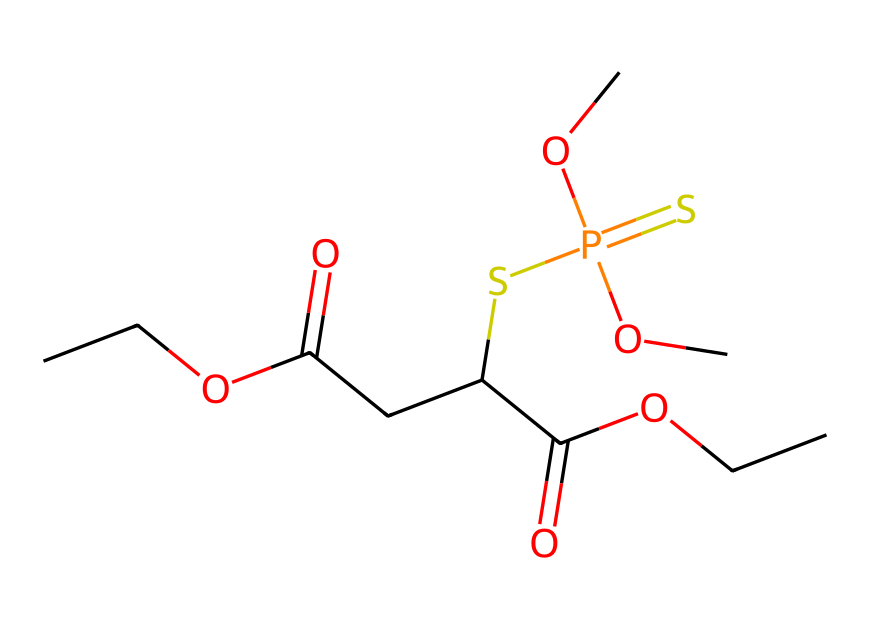How many carbon atoms are in malathion? By analyzing the SMILES representation, you can identify the carbon atoms (C). Each 'C' symbol corresponds to a carbon atom. Counting them, there are 10 carbon atoms present in the structure.
Answer: 10 What functional groups are present in malathion? In the SMILES, we can see indications of ester (C(=O)O) and thiophosphate groups (SP(=S)). The presence of these specific arrangements indicates these functional groups.
Answer: ester and thiophosphate How many sulfur atoms are in malathion? Looking at the SMILES notation, there is one 'S' present in the structure, indicating one sulfur atom. Additionally, you can see 'SP' indicating another sulfur involvement. Thus, there are 2 sulfur atoms.
Answer: 2 What is the total number of oxygen atoms in malathion? In the SMILES structure, each 'O' symbol corresponds to an oxygen atom. By counting them, there are a total of 6 oxygen atoms present in the structure.
Answer: 6 What type of pesticide is malathion classified as? Malathion is classified as an organophosphate insecticide. This classification is reflective of its structural groups that contain phosphorus and sulfur, common in organophosphates.
Answer: organophosphate What makes malathion significant in historical context? Malathion has historical significance due to its widespread use in agricultural practices and urban pest control, especially during the mid-20th century, highlighting its impact on crop management and health policies.
Answer: widespread use 